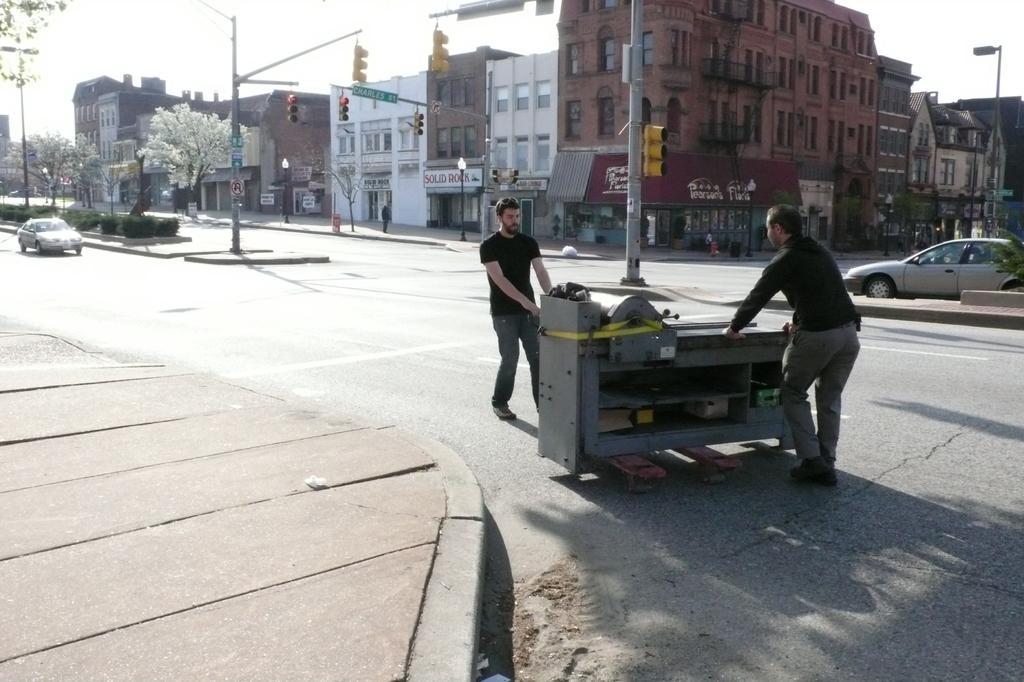Could you give a brief overview of what you see in this image? In this image I can see the road. On the road I can see some vehicles and two people holding an ash color object. To the side of the road I can see many trees and the poles. In the background I can see the buildings with many boards and the sky. 